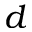Convert formula to latex. <formula><loc_0><loc_0><loc_500><loc_500>d</formula> 